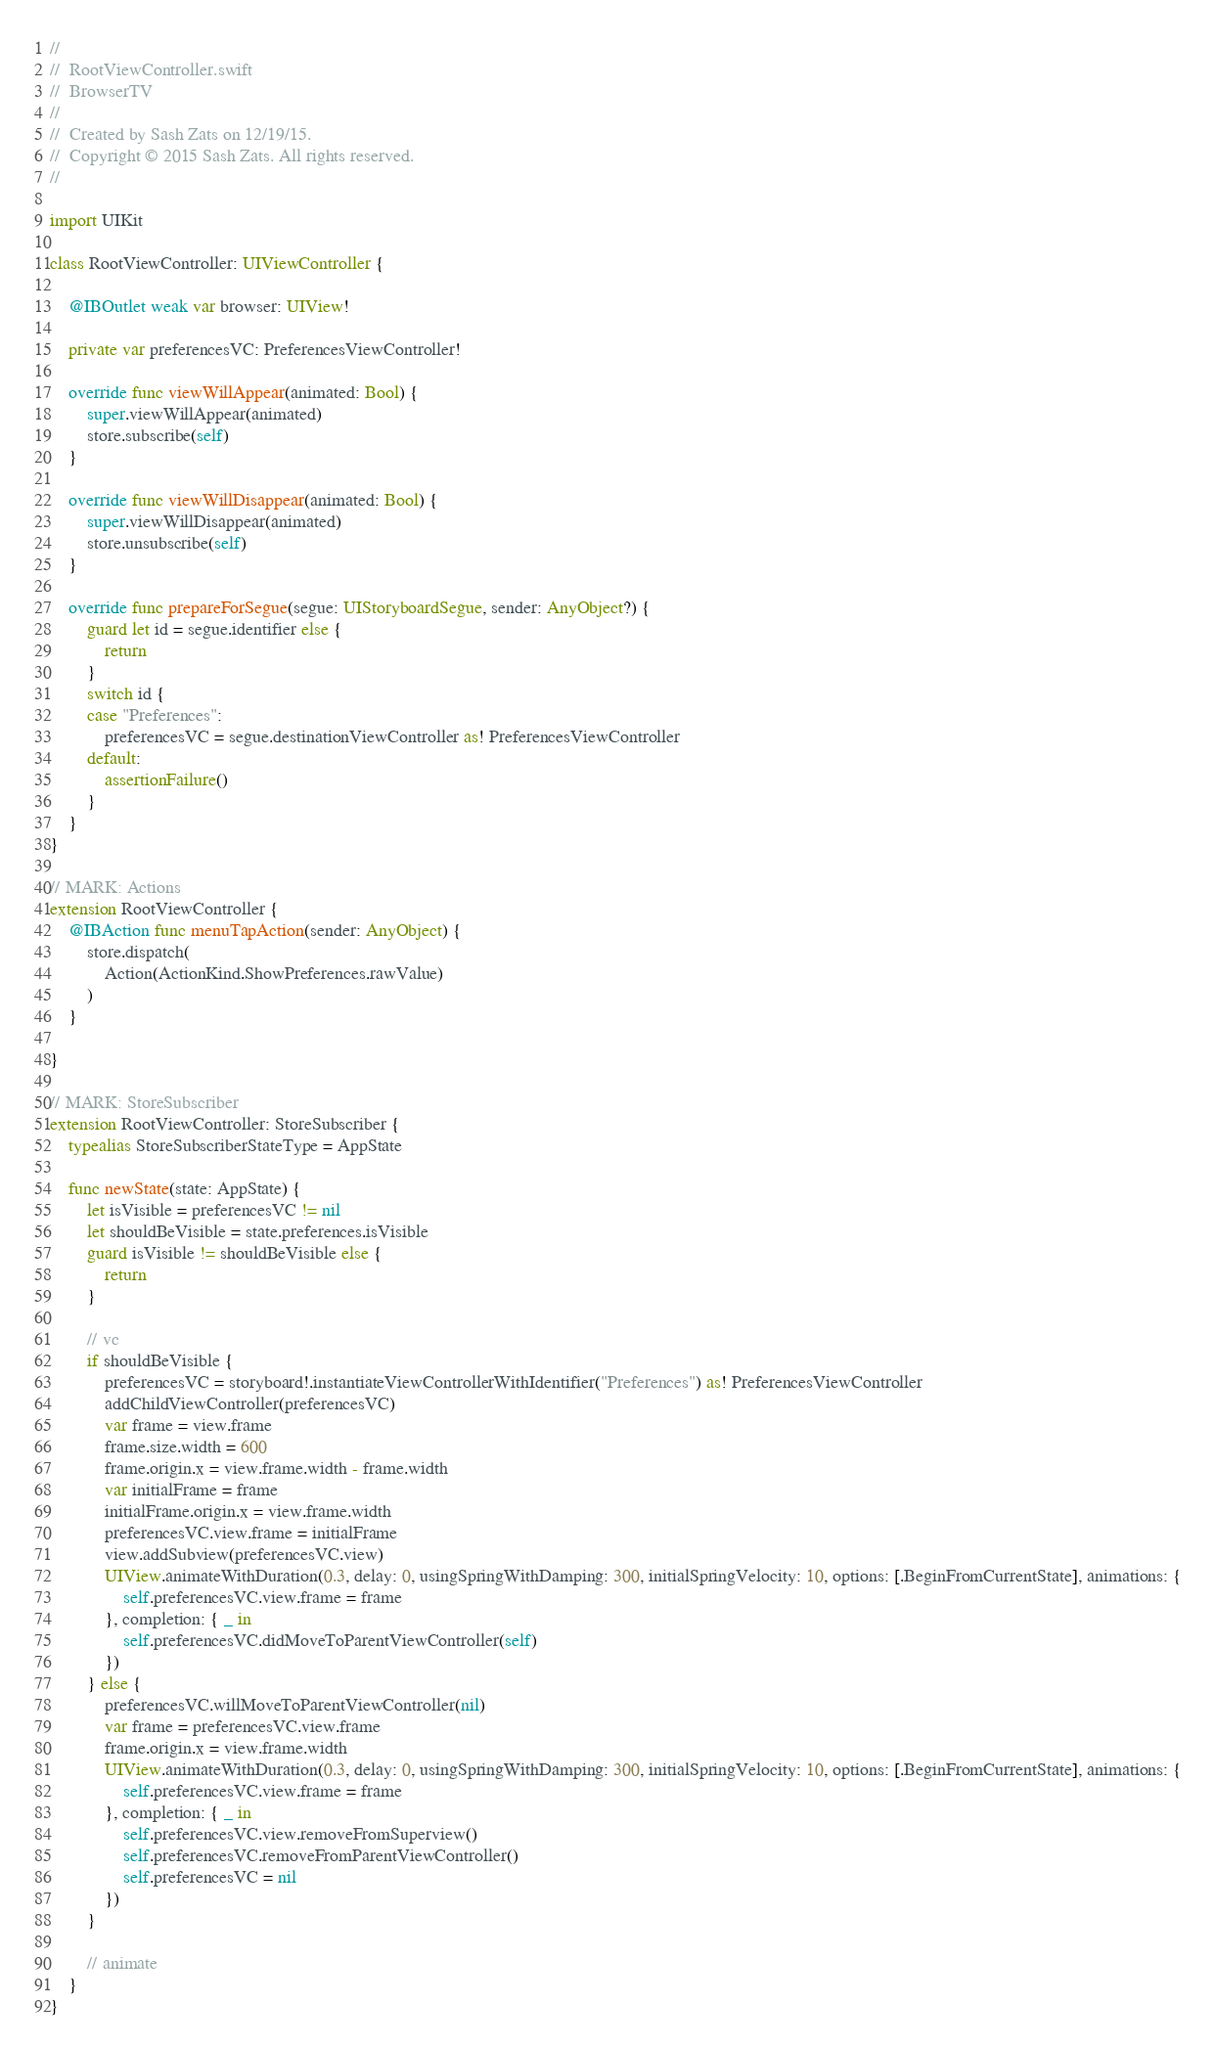Convert code to text. <code><loc_0><loc_0><loc_500><loc_500><_Swift_>//
//  RootViewController.swift
//  BrowserTV
//
//  Created by Sash Zats on 12/19/15.
//  Copyright © 2015 Sash Zats. All rights reserved.
//

import UIKit

class RootViewController: UIViewController {

    @IBOutlet weak var browser: UIView!

    private var preferencesVC: PreferencesViewController!
    
    override func viewWillAppear(animated: Bool) {
        super.viewWillAppear(animated)
        store.subscribe(self)
    }
    
    override func viewWillDisappear(animated: Bool) {
        super.viewWillDisappear(animated)
        store.unsubscribe(self)
    }
    
    override func prepareForSegue(segue: UIStoryboardSegue, sender: AnyObject?) {
        guard let id = segue.identifier else {
            return
        }
        switch id {
        case "Preferences":
            preferencesVC = segue.destinationViewController as! PreferencesViewController
        default:
            assertionFailure()
        }
    }
}

// MARK: Actions
extension RootViewController {
    @IBAction func menuTapAction(sender: AnyObject) {
        store.dispatch(
            Action(ActionKind.ShowPreferences.rawValue)
        )
    }
    
}

// MARK: StoreSubscriber
extension RootViewController: StoreSubscriber {
    typealias StoreSubscriberStateType = AppState
    
    func newState(state: AppState) {
        let isVisible = preferencesVC != nil
        let shouldBeVisible = state.preferences.isVisible
        guard isVisible != shouldBeVisible else {
            return
        }
        
        // vc
        if shouldBeVisible {
            preferencesVC = storyboard!.instantiateViewControllerWithIdentifier("Preferences") as! PreferencesViewController
            addChildViewController(preferencesVC)
            var frame = view.frame
            frame.size.width = 600
            frame.origin.x = view.frame.width - frame.width
            var initialFrame = frame
            initialFrame.origin.x = view.frame.width
            preferencesVC.view.frame = initialFrame
            view.addSubview(preferencesVC.view)
            UIView.animateWithDuration(0.3, delay: 0, usingSpringWithDamping: 300, initialSpringVelocity: 10, options: [.BeginFromCurrentState], animations: {
                self.preferencesVC.view.frame = frame
            }, completion: { _ in
                self.preferencesVC.didMoveToParentViewController(self)
            })
        } else {
            preferencesVC.willMoveToParentViewController(nil)
            var frame = preferencesVC.view.frame
            frame.origin.x = view.frame.width
            UIView.animateWithDuration(0.3, delay: 0, usingSpringWithDamping: 300, initialSpringVelocity: 10, options: [.BeginFromCurrentState], animations: {
                self.preferencesVC.view.frame = frame
            }, completion: { _ in
                self.preferencesVC.view.removeFromSuperview()
                self.preferencesVC.removeFromParentViewController()
                self.preferencesVC = nil
            })
        }
        
        // animate
    }
}
</code> 